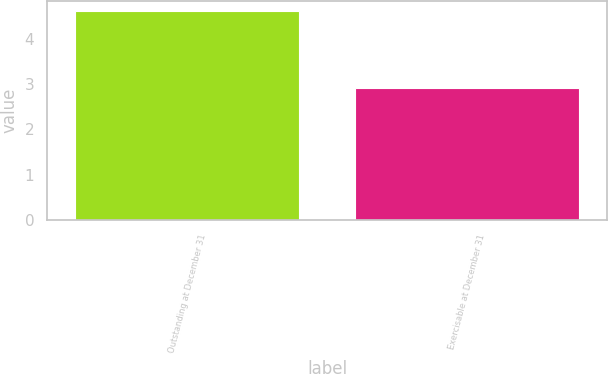<chart> <loc_0><loc_0><loc_500><loc_500><bar_chart><fcel>Outstanding at December 31<fcel>Exercisable at December 31<nl><fcel>4.6<fcel>2.9<nl></chart> 